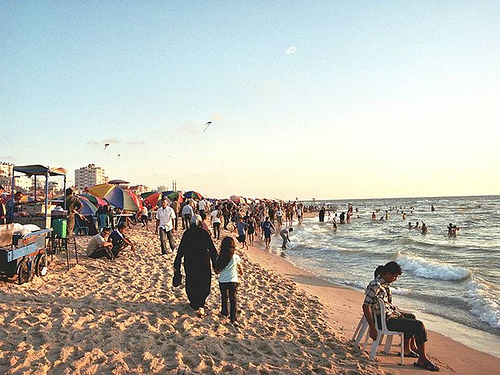Are there any people to the left of the cart? No, the area to the left of the blue cart is clear of people, providing an unobstructed path along the beach. 